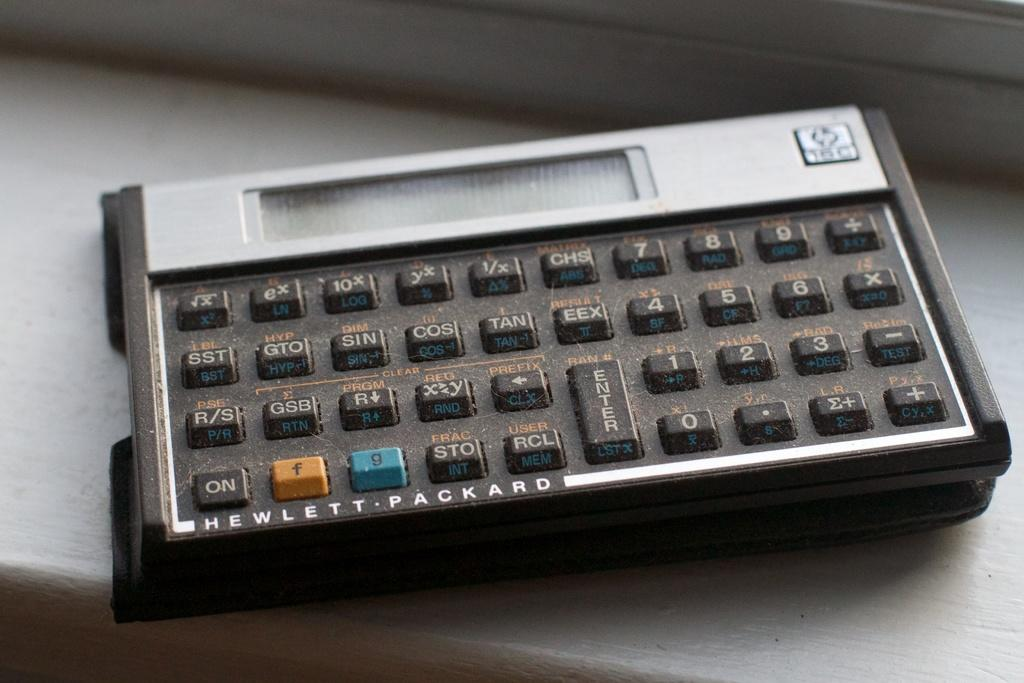<image>
Share a concise interpretation of the image provided. a Hewlett Packard calculator with black, blue, and orange keys 